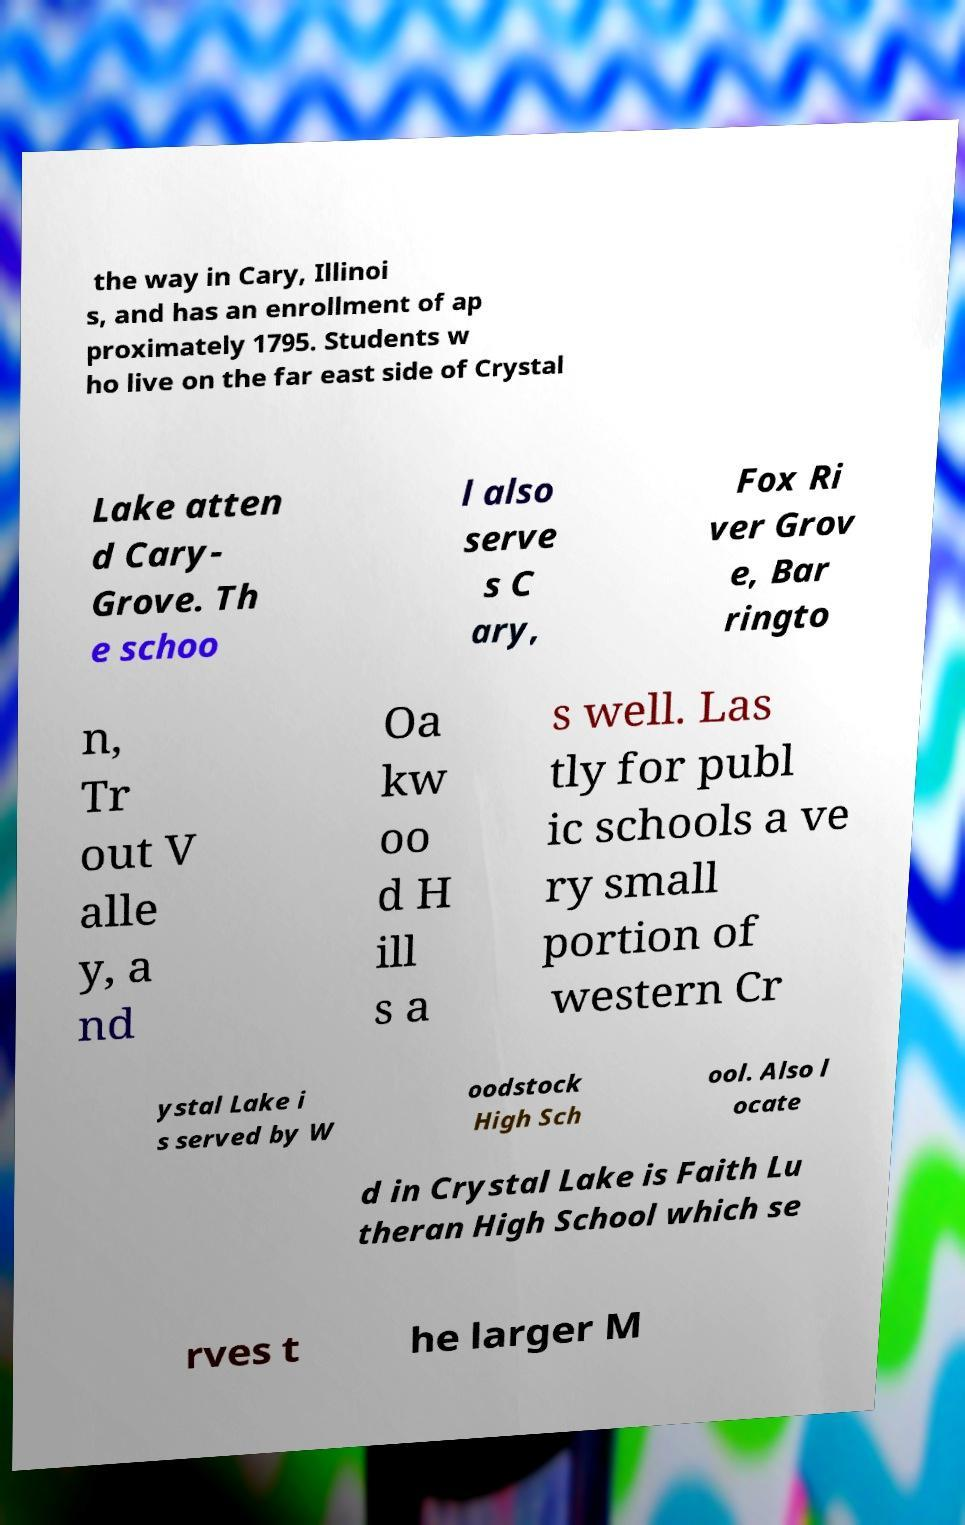Could you assist in decoding the text presented in this image and type it out clearly? the way in Cary, Illinoi s, and has an enrollment of ap proximately 1795. Students w ho live on the far east side of Crystal Lake atten d Cary- Grove. Th e schoo l also serve s C ary, Fox Ri ver Grov e, Bar ringto n, Tr out V alle y, a nd Oa kw oo d H ill s a s well. Las tly for publ ic schools a ve ry small portion of western Cr ystal Lake i s served by W oodstock High Sch ool. Also l ocate d in Crystal Lake is Faith Lu theran High School which se rves t he larger M 